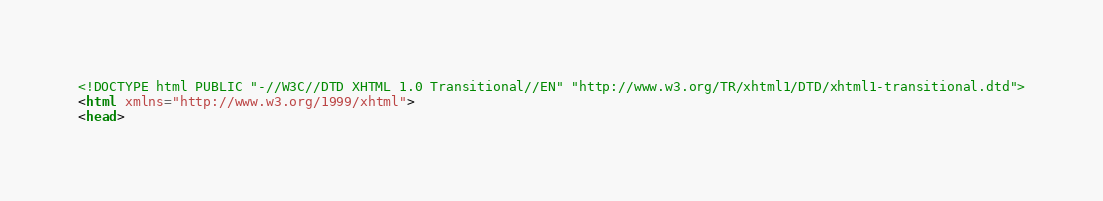<code> <loc_0><loc_0><loc_500><loc_500><_HTML_><!DOCTYPE html PUBLIC "-//W3C//DTD XHTML 1.0 Transitional//EN" "http://www.w3.org/TR/xhtml1/DTD/xhtml1-transitional.dtd">
<html xmlns="http://www.w3.org/1999/xhtml">
<head></code> 